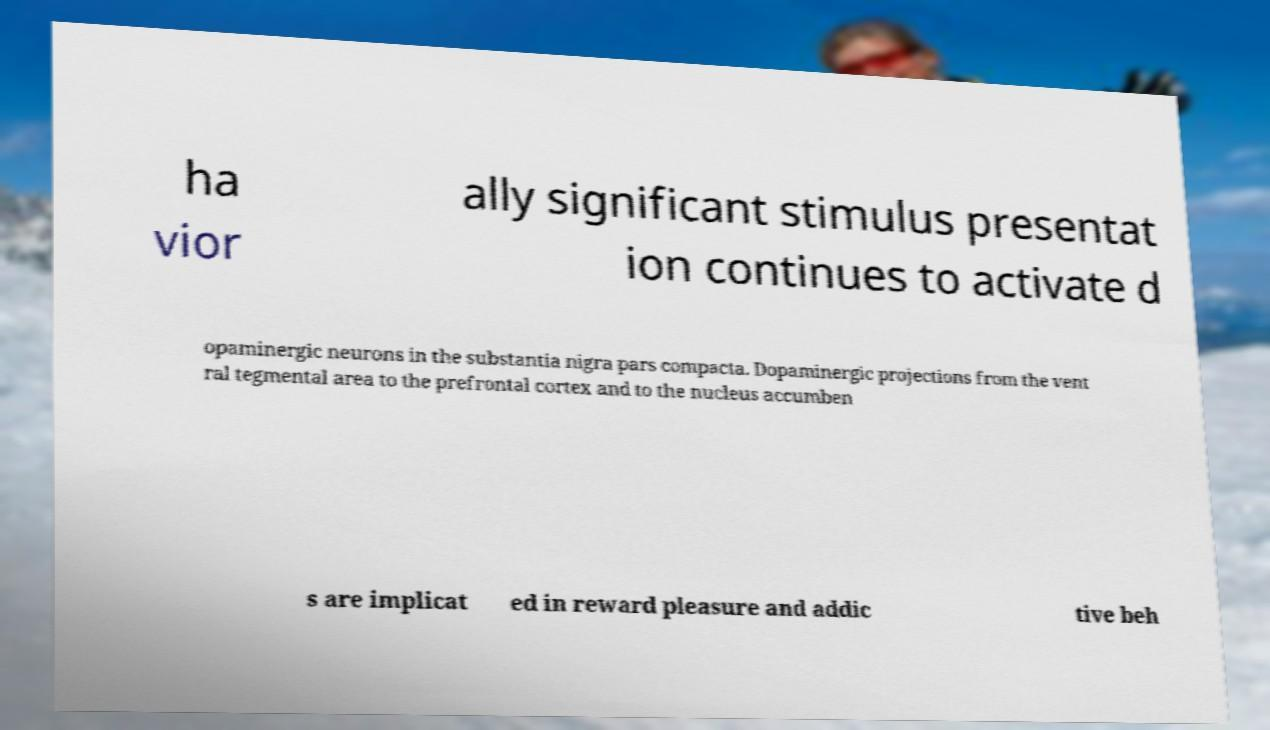Please identify and transcribe the text found in this image. ha vior ally significant stimulus presentat ion continues to activate d opaminergic neurons in the substantia nigra pars compacta. Dopaminergic projections from the vent ral tegmental area to the prefrontal cortex and to the nucleus accumben s are implicat ed in reward pleasure and addic tive beh 